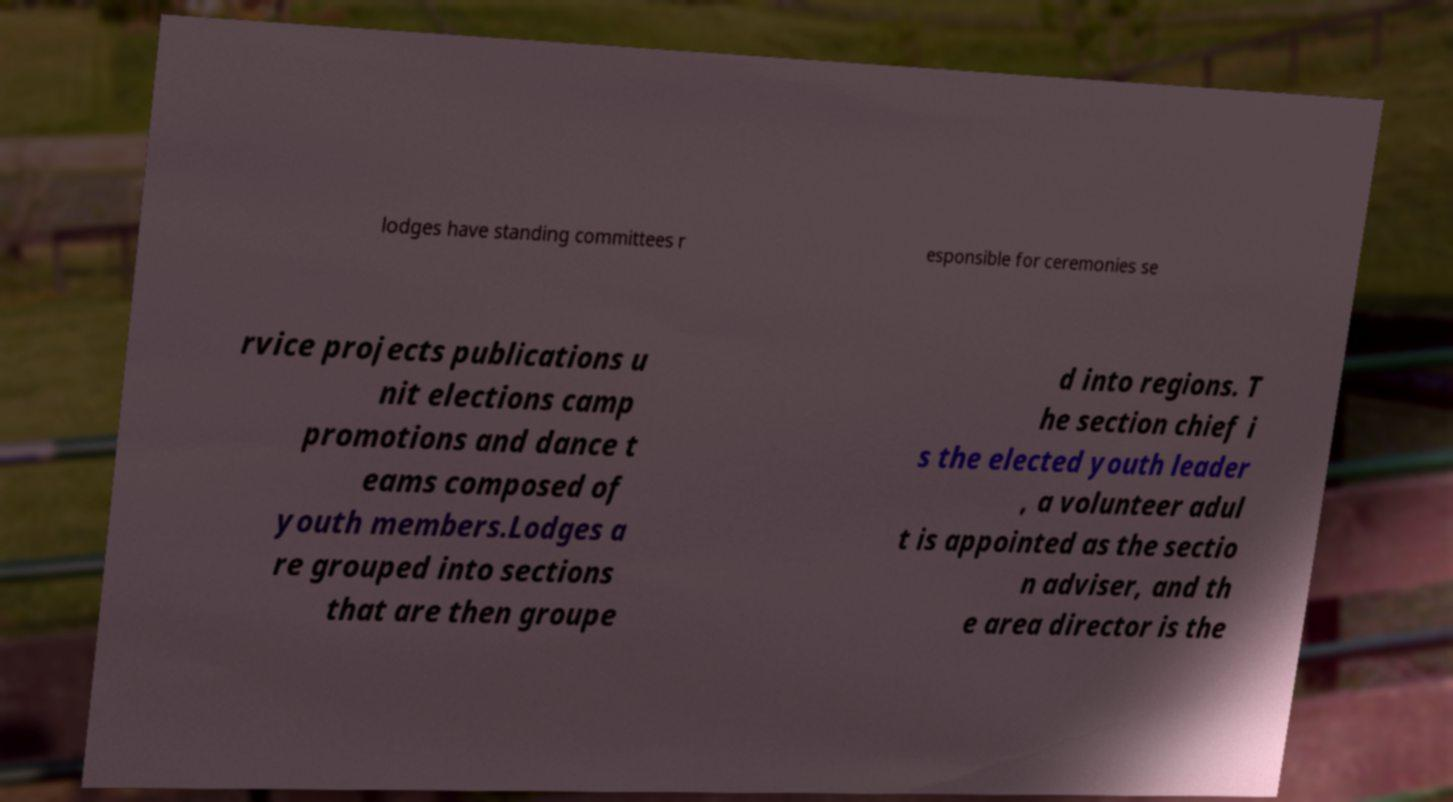Can you accurately transcribe the text from the provided image for me? lodges have standing committees r esponsible for ceremonies se rvice projects publications u nit elections camp promotions and dance t eams composed of youth members.Lodges a re grouped into sections that are then groupe d into regions. T he section chief i s the elected youth leader , a volunteer adul t is appointed as the sectio n adviser, and th e area director is the 